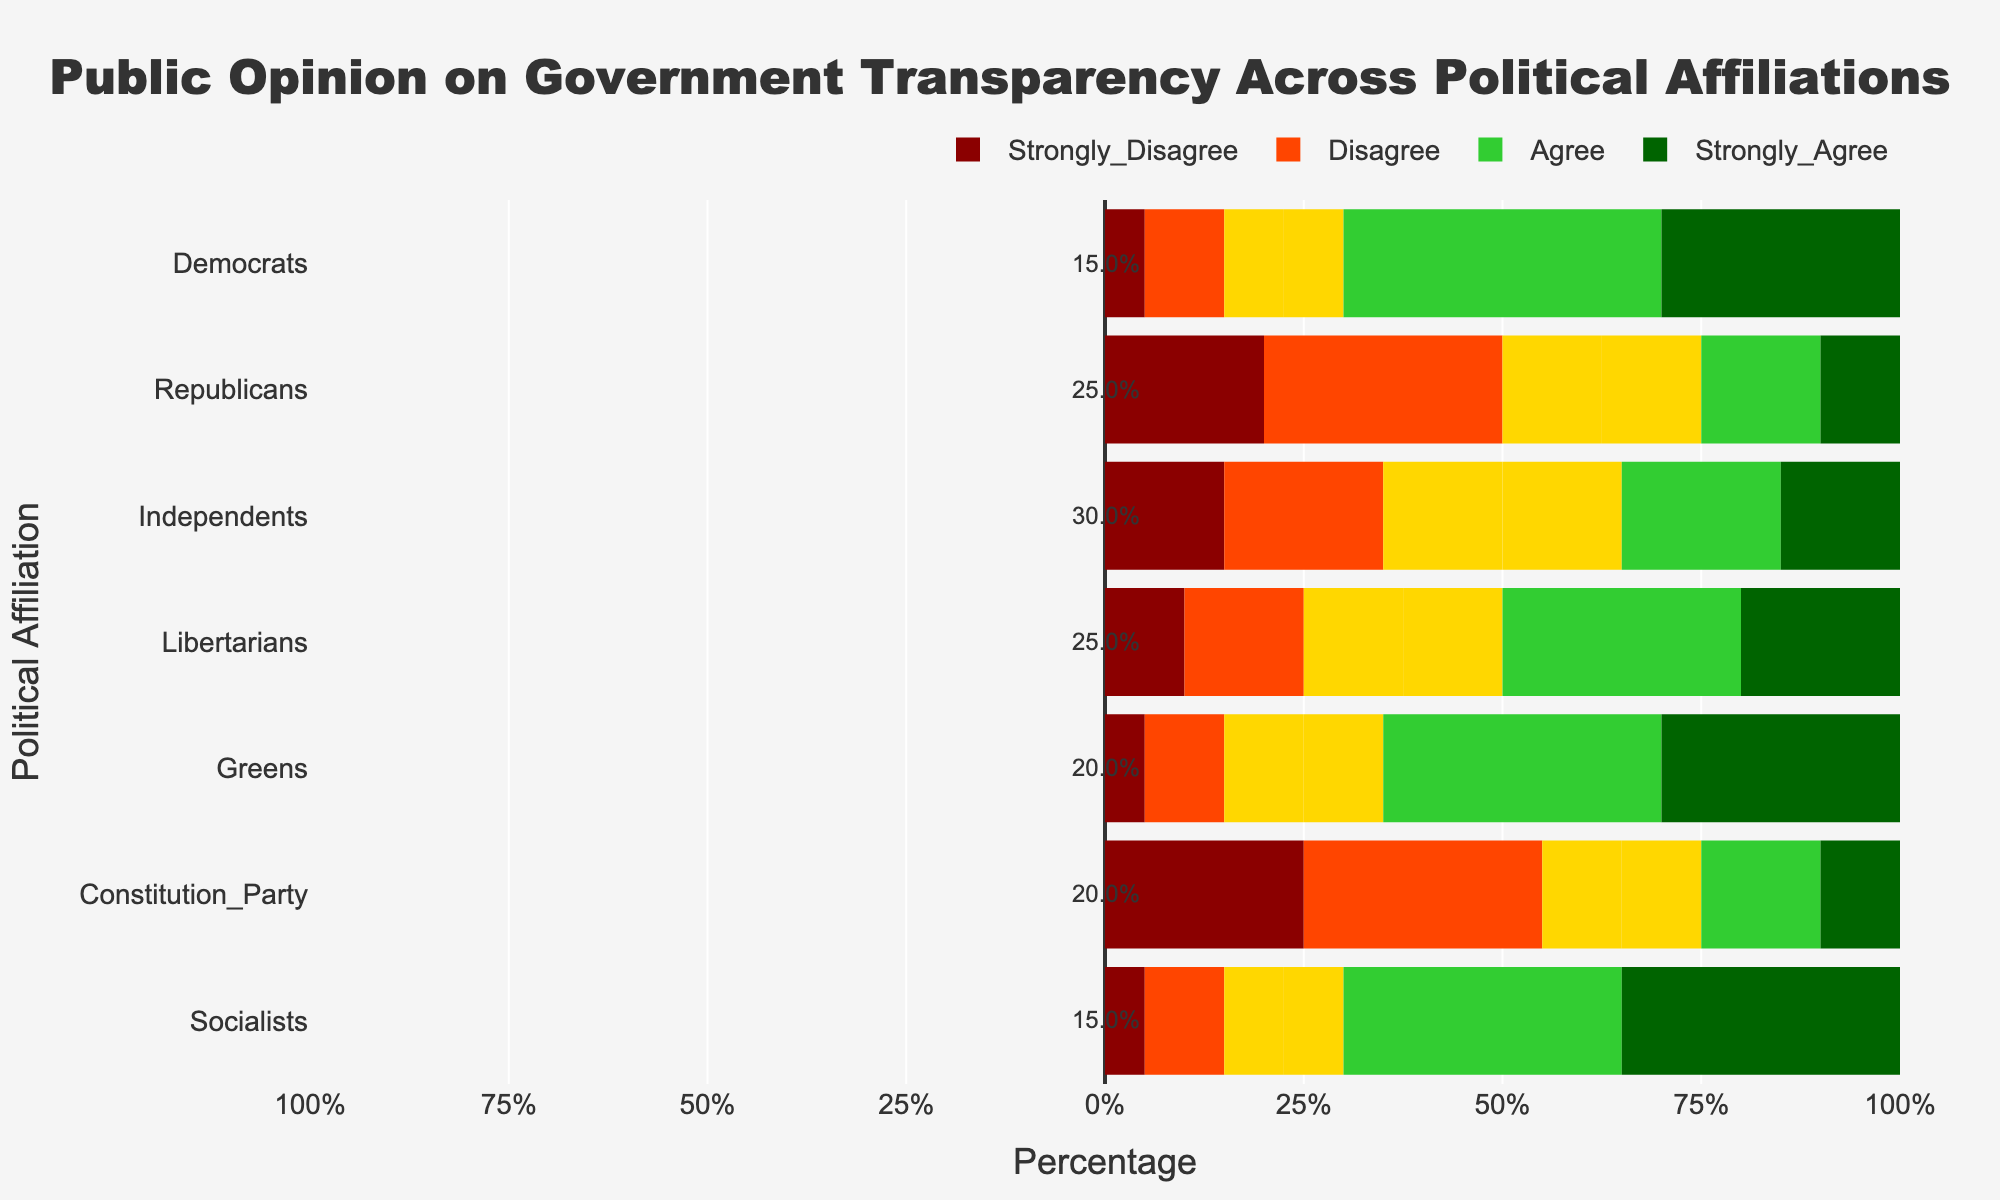Which political affiliation has the highest percentage of agreement (combined Agree and Strongly Agree) on government transparency? To determine the highest percentage of agreement, add the percentages of Agree and Strongly Agree categories for each political affiliation. Compare the sums across all affiliations.
Answer: Socialists Which political affiliation has the lowest percentage of disagreement (combined Strongly Disagree and Disagree) on government transparency? To find the lowest percentage of disagreement, sum the percentages of Strongly Disagree and Disagree categories for each political affiliation. Identify the affiliation with the smallest sum.
Answer: Democrats What is the difference in the percentage of Strongly Agree between Democrats and Republicans? Locate the percentage of Strongly Agree for both Democrats (30%) and Republicans (10%). Subtract the latter from the former (30% - 10%).
Answer: 20% Which affiliation has the highest neutrality (Neutral category) regarding government transparency? Identify the affiliation with the largest percentage value under the Neutral category (adjusted for pitting left and right).
Answer: Independents What is the overall trend in opinion about government transparency among Independents compared to Greens? Examine the percentage distribution across all categories (Strongly Disagree, Disagree, Neutral, Agree, Strongly Agree) for both Independents and Greens. Note the higher neutrality and the more positive Agree and Strongly Agree percentages for Greens.
Answer: Greens are more positive Which two political affiliations have similar percentages of Strongly Disagree and Strongly Agree combined? Add the percentages of Strongly Disagree and Strongly Agree for each political affiliation. Compare the sums to find the closest values.
Answer: Republicans and Constitution Party How do Libertarians compare to Democrats in terms of overall positive opinion (Agree and Strongly Agree combined) on government transparency? Sum the percentages of Agree and Strongly Agree for both Libertarians (50%) and Democrats (70%). Determine that the Libertarians have a lower positive opinion compared to Democrats.
Answer: Democrats have higher What percentage of Socialists agrees with government transparency (Agree + Strongly Agree)? Add the percentages of Agree (35%) and Strongly Agree (35%) for Socialists.
Answer: 70% Among the given political affiliations, which one shows the least variance in opinions about government transparency? Assess the range (max value - min value) of percentages for each affiliation across all categories. The affiliation with the smallest range shows the least variance.
Answer: Greens What proportion of Republicans disagrees (Disagree and Strongly Disagree combined) with government transparency? Add the percentages of Disagree (30%) and Strongly Disagree (20%) for Republicans.
Answer: 50% 